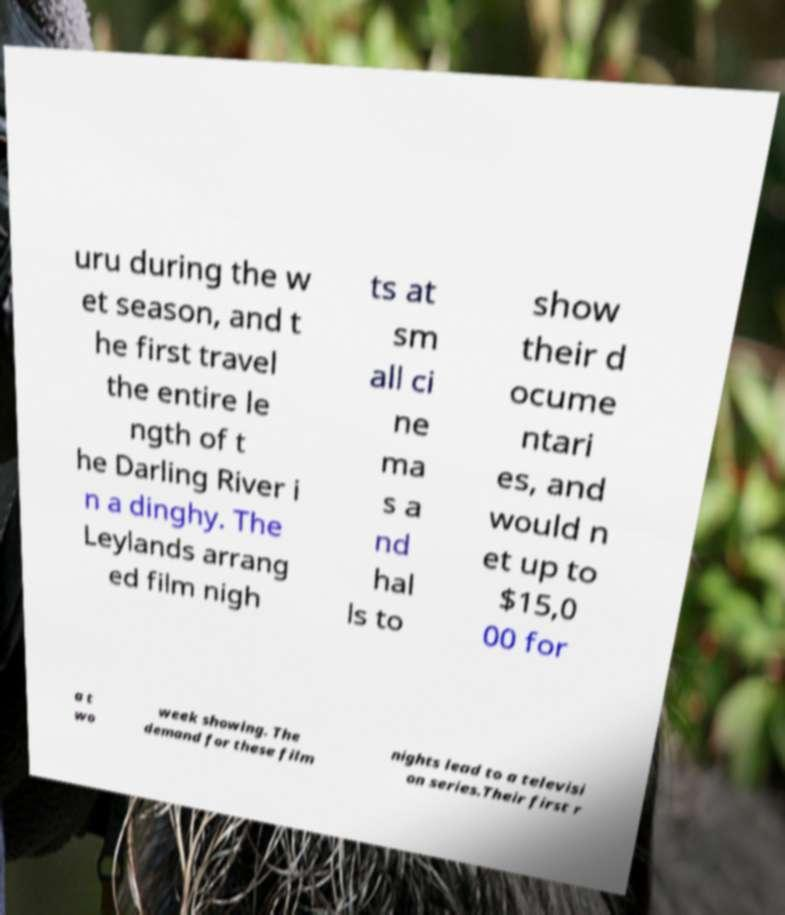Could you extract and type out the text from this image? uru during the w et season, and t he first travel the entire le ngth of t he Darling River i n a dinghy. The Leylands arrang ed film nigh ts at sm all ci ne ma s a nd hal ls to show their d ocume ntari es, and would n et up to $15,0 00 for a t wo week showing. The demand for these film nights lead to a televisi on series.Their first r 